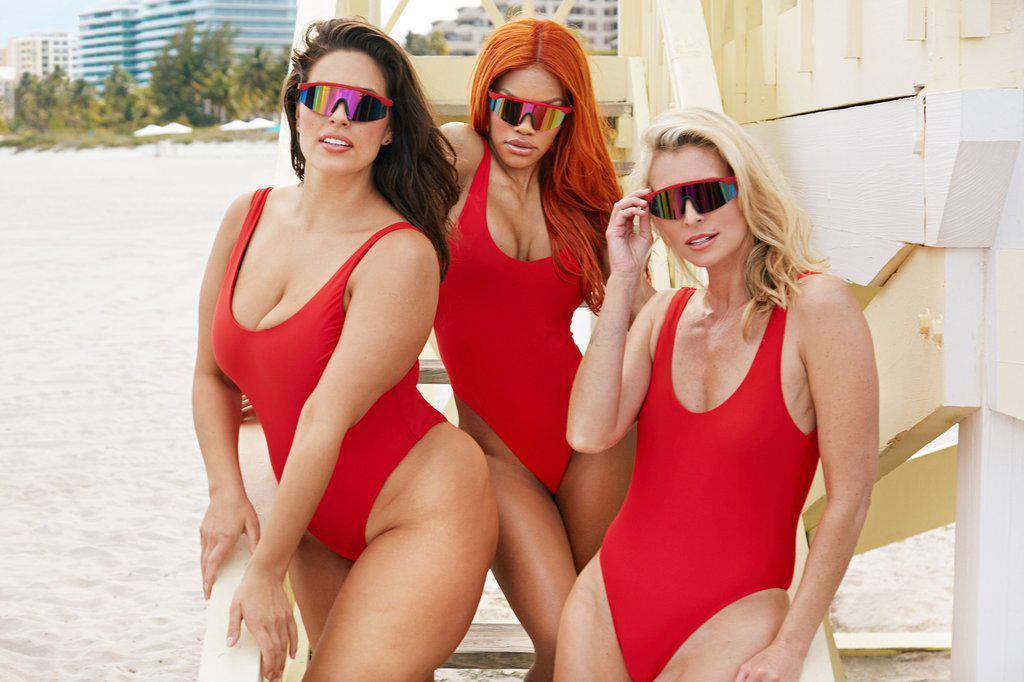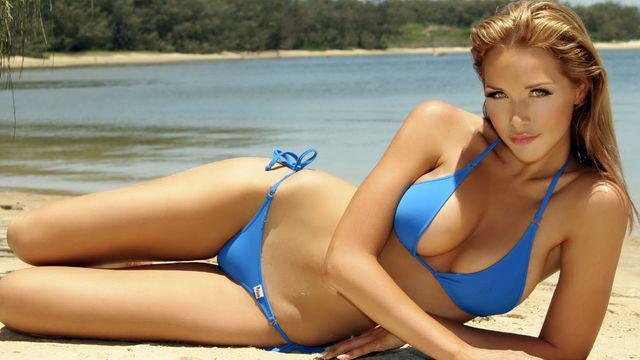The first image is the image on the left, the second image is the image on the right. Assess this claim about the two images: "A woman is wearing a red polka dot swimsuit.". Correct or not? Answer yes or no. No. The first image is the image on the left, the second image is the image on the right. Given the left and right images, does the statement "An image shows a trio of swimwear models, with at least one wearing a one-piece suit." hold true? Answer yes or no. Yes. 